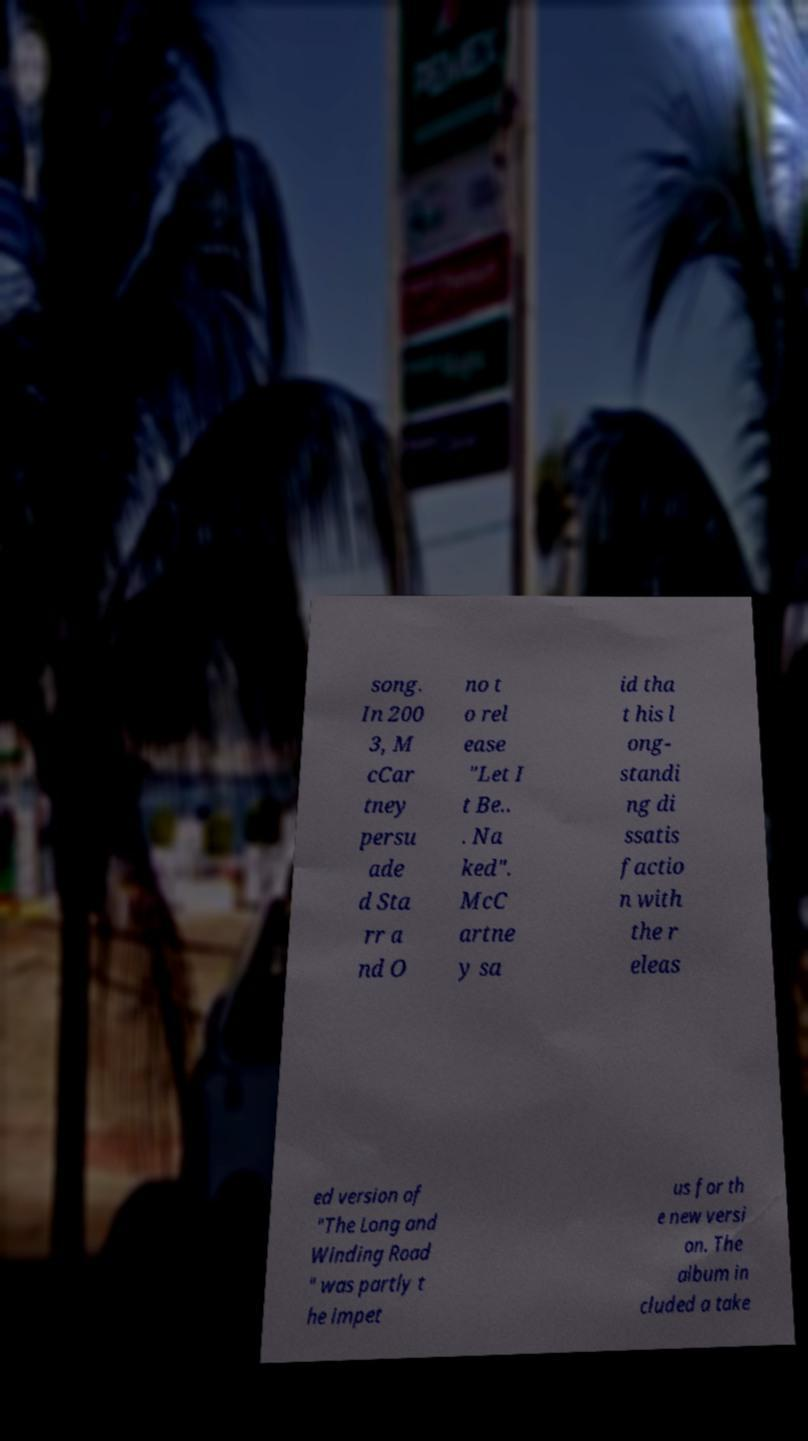There's text embedded in this image that I need extracted. Can you transcribe it verbatim? song. In 200 3, M cCar tney persu ade d Sta rr a nd O no t o rel ease "Let I t Be.. . Na ked". McC artne y sa id tha t his l ong- standi ng di ssatis factio n with the r eleas ed version of "The Long and Winding Road " was partly t he impet us for th e new versi on. The album in cluded a take 